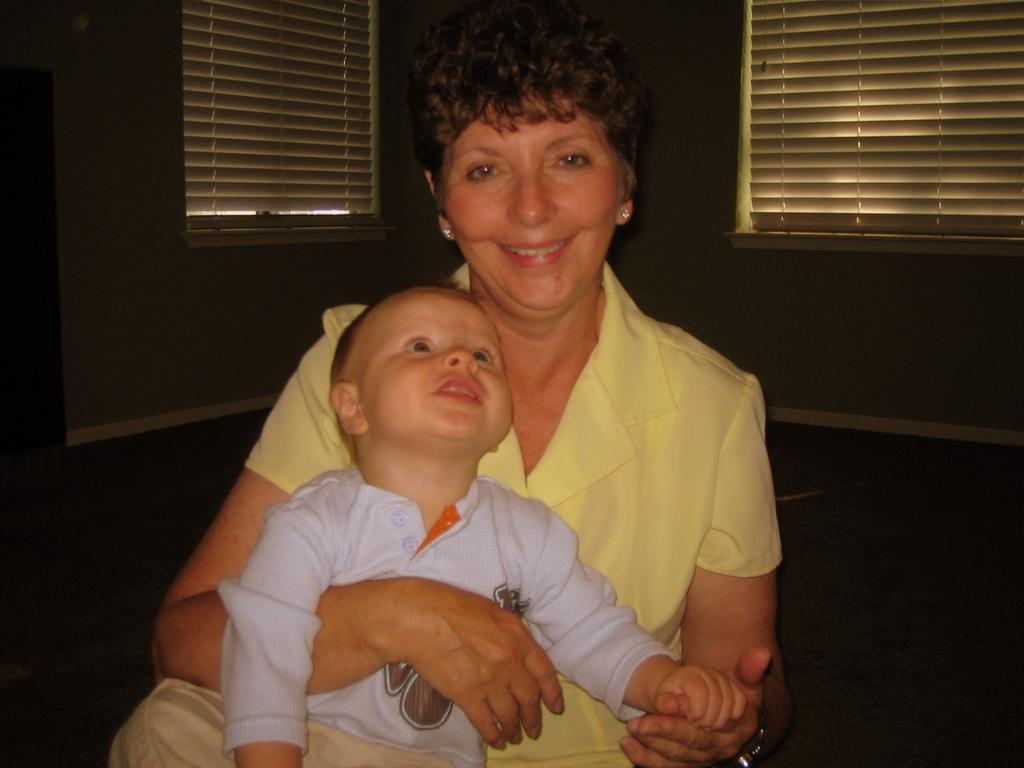How would you summarize this image in a sentence or two? In the center of the image there is a lady holding a boy. In the background of the image there is a window. There is a wall. 